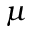<formula> <loc_0><loc_0><loc_500><loc_500>\mu</formula> 